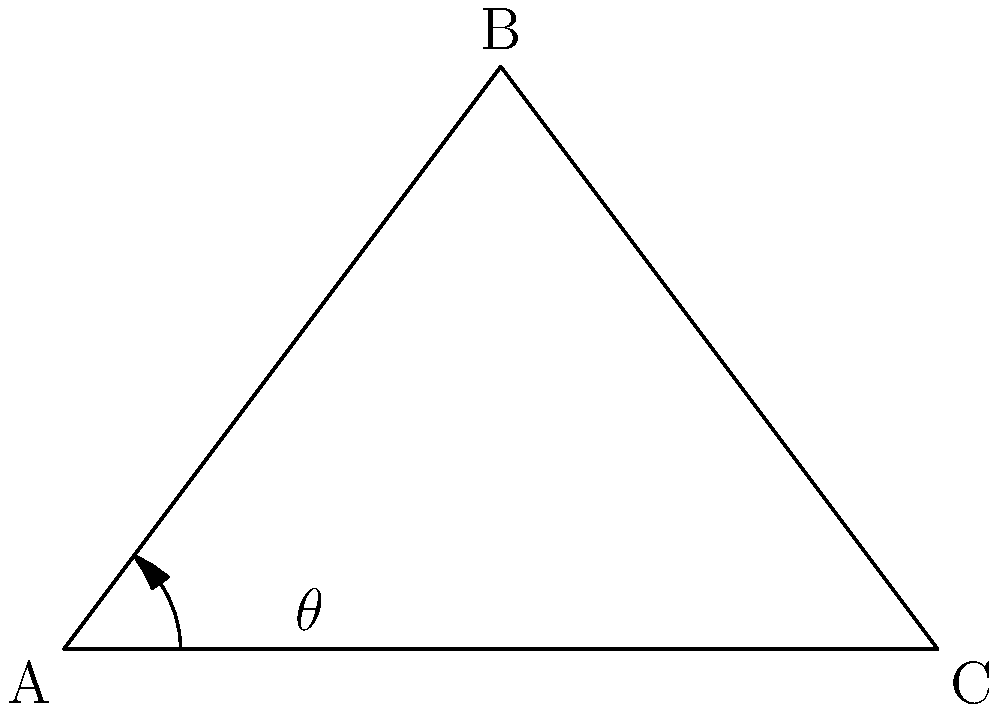In a new music video choreography, the lead dancer's arm forms a triangle with their torso. If the shoulder joint (A) and hip joint (C) are 6 units apart on the ground, and the elbow joint (B) forms the apex of the triangle 4 units above the ground, what is the angle θ (in degrees) at the shoulder joint? To solve this problem, we'll use trigonometry:

1. First, let's identify the triangle: ABC, where A is the shoulder, B is the elbow, and C is the hip.

2. We're given:
   - AC (base) = 6 units
   - Height of B from AC = 4 units

3. To find angle θ, we need to use the arctangent function.

4. We can split the triangle into two right triangles. Let's focus on the right triangle formed by the height from B to AC.

5. In this right triangle:
   - The opposite side (height) = 4 units
   - The adjacent side (half of AC) = 3 units (since AC = 6, and B's height splits it in half)

6. Using the tangent function:
   $$\tan(\theta) = \frac{\text{opposite}}{\text{adjacent}} = \frac{4}{3}$$

7. To find θ, we take the arctangent (inverse tangent) of this ratio:
   $$\theta = \arctan(\frac{4}{3})$$

8. Using a calculator or programming function:
   $$\theta \approx 53.13\text{ degrees}$$

9. Rounding to the nearest degree:
   $$\theta \approx 53\text{ degrees}$$
Answer: 53 degrees 